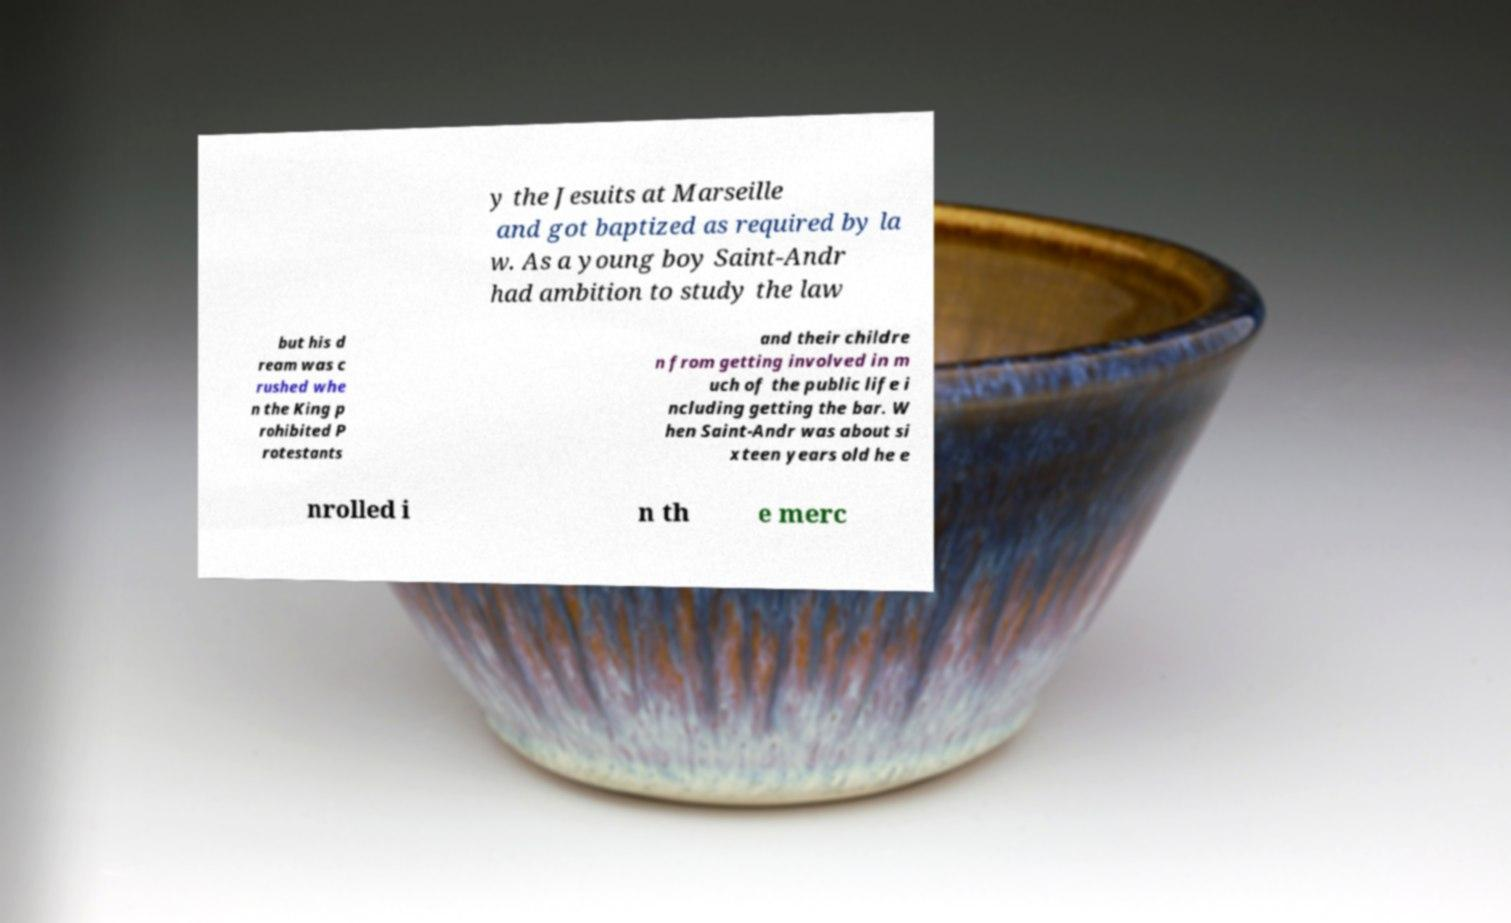Could you extract and type out the text from this image? y the Jesuits at Marseille and got baptized as required by la w. As a young boy Saint-Andr had ambition to study the law but his d ream was c rushed whe n the King p rohibited P rotestants and their childre n from getting involved in m uch of the public life i ncluding getting the bar. W hen Saint-Andr was about si xteen years old he e nrolled i n th e merc 